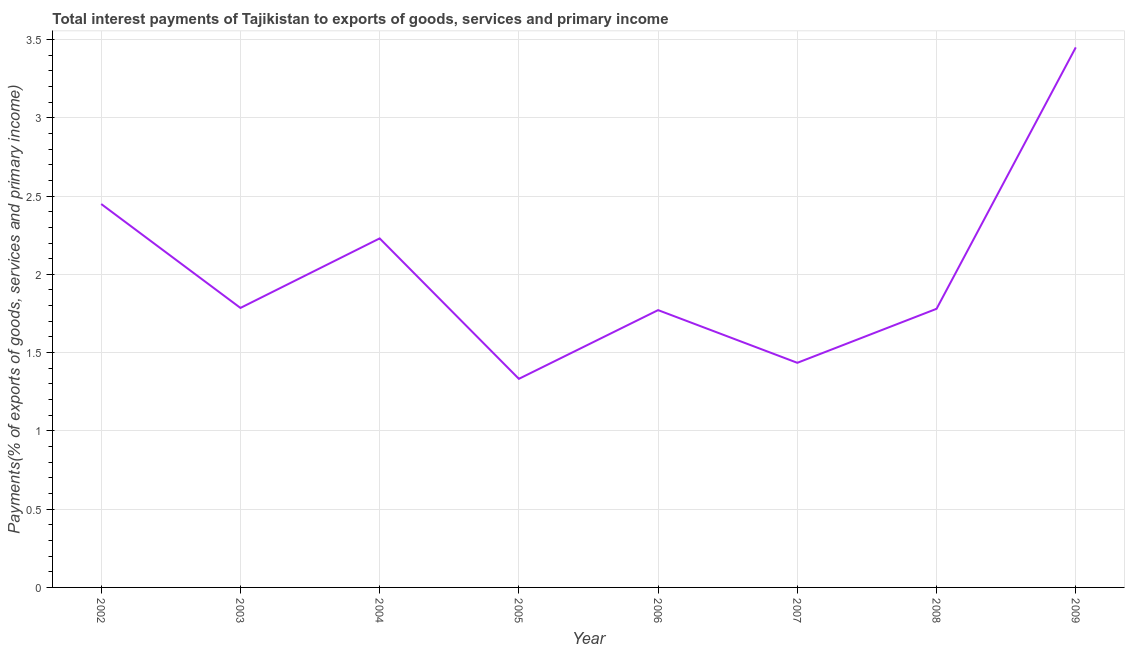What is the total interest payments on external debt in 2005?
Your answer should be compact. 1.33. Across all years, what is the maximum total interest payments on external debt?
Provide a succinct answer. 3.45. Across all years, what is the minimum total interest payments on external debt?
Provide a succinct answer. 1.33. In which year was the total interest payments on external debt maximum?
Make the answer very short. 2009. What is the sum of the total interest payments on external debt?
Provide a short and direct response. 16.23. What is the difference between the total interest payments on external debt in 2004 and 2007?
Offer a terse response. 0.79. What is the average total interest payments on external debt per year?
Make the answer very short. 2.03. What is the median total interest payments on external debt?
Provide a succinct answer. 1.78. What is the ratio of the total interest payments on external debt in 2007 to that in 2008?
Provide a short and direct response. 0.81. Is the total interest payments on external debt in 2002 less than that in 2004?
Provide a short and direct response. No. What is the difference between the highest and the second highest total interest payments on external debt?
Your answer should be compact. 1. What is the difference between the highest and the lowest total interest payments on external debt?
Make the answer very short. 2.12. In how many years, is the total interest payments on external debt greater than the average total interest payments on external debt taken over all years?
Make the answer very short. 3. Does the total interest payments on external debt monotonically increase over the years?
Make the answer very short. No. How many lines are there?
Make the answer very short. 1. How many years are there in the graph?
Keep it short and to the point. 8. Are the values on the major ticks of Y-axis written in scientific E-notation?
Your answer should be very brief. No. What is the title of the graph?
Ensure brevity in your answer.  Total interest payments of Tajikistan to exports of goods, services and primary income. What is the label or title of the X-axis?
Make the answer very short. Year. What is the label or title of the Y-axis?
Provide a short and direct response. Payments(% of exports of goods, services and primary income). What is the Payments(% of exports of goods, services and primary income) of 2002?
Ensure brevity in your answer.  2.45. What is the Payments(% of exports of goods, services and primary income) of 2003?
Provide a short and direct response. 1.79. What is the Payments(% of exports of goods, services and primary income) in 2004?
Make the answer very short. 2.23. What is the Payments(% of exports of goods, services and primary income) in 2005?
Offer a very short reply. 1.33. What is the Payments(% of exports of goods, services and primary income) in 2006?
Offer a very short reply. 1.77. What is the Payments(% of exports of goods, services and primary income) of 2007?
Give a very brief answer. 1.43. What is the Payments(% of exports of goods, services and primary income) of 2008?
Make the answer very short. 1.78. What is the Payments(% of exports of goods, services and primary income) of 2009?
Ensure brevity in your answer.  3.45. What is the difference between the Payments(% of exports of goods, services and primary income) in 2002 and 2003?
Your answer should be very brief. 0.66. What is the difference between the Payments(% of exports of goods, services and primary income) in 2002 and 2004?
Your response must be concise. 0.22. What is the difference between the Payments(% of exports of goods, services and primary income) in 2002 and 2005?
Offer a very short reply. 1.12. What is the difference between the Payments(% of exports of goods, services and primary income) in 2002 and 2006?
Make the answer very short. 0.68. What is the difference between the Payments(% of exports of goods, services and primary income) in 2002 and 2007?
Offer a very short reply. 1.01. What is the difference between the Payments(% of exports of goods, services and primary income) in 2002 and 2008?
Provide a succinct answer. 0.67. What is the difference between the Payments(% of exports of goods, services and primary income) in 2002 and 2009?
Keep it short and to the point. -1. What is the difference between the Payments(% of exports of goods, services and primary income) in 2003 and 2004?
Provide a succinct answer. -0.44. What is the difference between the Payments(% of exports of goods, services and primary income) in 2003 and 2005?
Your answer should be compact. 0.45. What is the difference between the Payments(% of exports of goods, services and primary income) in 2003 and 2006?
Offer a terse response. 0.01. What is the difference between the Payments(% of exports of goods, services and primary income) in 2003 and 2007?
Provide a succinct answer. 0.35. What is the difference between the Payments(% of exports of goods, services and primary income) in 2003 and 2008?
Offer a terse response. 0.01. What is the difference between the Payments(% of exports of goods, services and primary income) in 2003 and 2009?
Give a very brief answer. -1.66. What is the difference between the Payments(% of exports of goods, services and primary income) in 2004 and 2005?
Offer a terse response. 0.9. What is the difference between the Payments(% of exports of goods, services and primary income) in 2004 and 2006?
Provide a short and direct response. 0.46. What is the difference between the Payments(% of exports of goods, services and primary income) in 2004 and 2007?
Your answer should be very brief. 0.79. What is the difference between the Payments(% of exports of goods, services and primary income) in 2004 and 2008?
Offer a terse response. 0.45. What is the difference between the Payments(% of exports of goods, services and primary income) in 2004 and 2009?
Your answer should be very brief. -1.22. What is the difference between the Payments(% of exports of goods, services and primary income) in 2005 and 2006?
Your response must be concise. -0.44. What is the difference between the Payments(% of exports of goods, services and primary income) in 2005 and 2007?
Ensure brevity in your answer.  -0.1. What is the difference between the Payments(% of exports of goods, services and primary income) in 2005 and 2008?
Your response must be concise. -0.45. What is the difference between the Payments(% of exports of goods, services and primary income) in 2005 and 2009?
Ensure brevity in your answer.  -2.12. What is the difference between the Payments(% of exports of goods, services and primary income) in 2006 and 2007?
Your answer should be very brief. 0.34. What is the difference between the Payments(% of exports of goods, services and primary income) in 2006 and 2008?
Make the answer very short. -0.01. What is the difference between the Payments(% of exports of goods, services and primary income) in 2006 and 2009?
Provide a succinct answer. -1.68. What is the difference between the Payments(% of exports of goods, services and primary income) in 2007 and 2008?
Give a very brief answer. -0.34. What is the difference between the Payments(% of exports of goods, services and primary income) in 2007 and 2009?
Your answer should be compact. -2.01. What is the difference between the Payments(% of exports of goods, services and primary income) in 2008 and 2009?
Ensure brevity in your answer.  -1.67. What is the ratio of the Payments(% of exports of goods, services and primary income) in 2002 to that in 2003?
Your answer should be very brief. 1.37. What is the ratio of the Payments(% of exports of goods, services and primary income) in 2002 to that in 2004?
Keep it short and to the point. 1.1. What is the ratio of the Payments(% of exports of goods, services and primary income) in 2002 to that in 2005?
Give a very brief answer. 1.84. What is the ratio of the Payments(% of exports of goods, services and primary income) in 2002 to that in 2006?
Keep it short and to the point. 1.38. What is the ratio of the Payments(% of exports of goods, services and primary income) in 2002 to that in 2007?
Make the answer very short. 1.71. What is the ratio of the Payments(% of exports of goods, services and primary income) in 2002 to that in 2008?
Ensure brevity in your answer.  1.38. What is the ratio of the Payments(% of exports of goods, services and primary income) in 2002 to that in 2009?
Make the answer very short. 0.71. What is the ratio of the Payments(% of exports of goods, services and primary income) in 2003 to that in 2004?
Provide a short and direct response. 0.8. What is the ratio of the Payments(% of exports of goods, services and primary income) in 2003 to that in 2005?
Provide a succinct answer. 1.34. What is the ratio of the Payments(% of exports of goods, services and primary income) in 2003 to that in 2007?
Offer a very short reply. 1.24. What is the ratio of the Payments(% of exports of goods, services and primary income) in 2003 to that in 2008?
Offer a terse response. 1. What is the ratio of the Payments(% of exports of goods, services and primary income) in 2003 to that in 2009?
Provide a succinct answer. 0.52. What is the ratio of the Payments(% of exports of goods, services and primary income) in 2004 to that in 2005?
Your answer should be very brief. 1.67. What is the ratio of the Payments(% of exports of goods, services and primary income) in 2004 to that in 2006?
Your answer should be very brief. 1.26. What is the ratio of the Payments(% of exports of goods, services and primary income) in 2004 to that in 2007?
Ensure brevity in your answer.  1.55. What is the ratio of the Payments(% of exports of goods, services and primary income) in 2004 to that in 2008?
Offer a very short reply. 1.25. What is the ratio of the Payments(% of exports of goods, services and primary income) in 2004 to that in 2009?
Provide a succinct answer. 0.65. What is the ratio of the Payments(% of exports of goods, services and primary income) in 2005 to that in 2006?
Your answer should be very brief. 0.75. What is the ratio of the Payments(% of exports of goods, services and primary income) in 2005 to that in 2007?
Give a very brief answer. 0.93. What is the ratio of the Payments(% of exports of goods, services and primary income) in 2005 to that in 2008?
Make the answer very short. 0.75. What is the ratio of the Payments(% of exports of goods, services and primary income) in 2005 to that in 2009?
Your answer should be compact. 0.39. What is the ratio of the Payments(% of exports of goods, services and primary income) in 2006 to that in 2007?
Provide a short and direct response. 1.24. What is the ratio of the Payments(% of exports of goods, services and primary income) in 2006 to that in 2008?
Your answer should be very brief. 0.99. What is the ratio of the Payments(% of exports of goods, services and primary income) in 2006 to that in 2009?
Provide a short and direct response. 0.51. What is the ratio of the Payments(% of exports of goods, services and primary income) in 2007 to that in 2008?
Offer a very short reply. 0.81. What is the ratio of the Payments(% of exports of goods, services and primary income) in 2007 to that in 2009?
Ensure brevity in your answer.  0.42. What is the ratio of the Payments(% of exports of goods, services and primary income) in 2008 to that in 2009?
Offer a terse response. 0.52. 